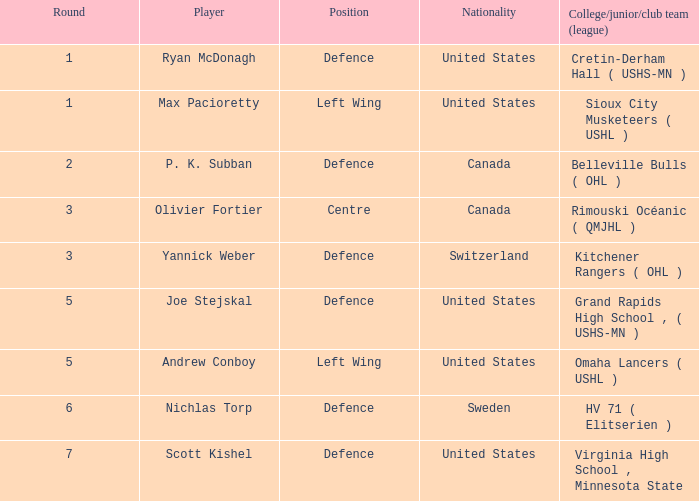Write the full table. {'header': ['Round', 'Player', 'Position', 'Nationality', 'College/junior/club team (league)'], 'rows': [['1', 'Ryan McDonagh', 'Defence', 'United States', 'Cretin-Derham Hall ( USHS-MN )'], ['1', 'Max Pacioretty', 'Left Wing', 'United States', 'Sioux City Musketeers ( USHL )'], ['2', 'P. K. Subban', 'Defence', 'Canada', 'Belleville Bulls ( OHL )'], ['3', 'Olivier Fortier', 'Centre', 'Canada', 'Rimouski Océanic ( QMJHL )'], ['3', 'Yannick Weber', 'Defence', 'Switzerland', 'Kitchener Rangers ( OHL )'], ['5', 'Joe Stejskal', 'Defence', 'United States', 'Grand Rapids High School , ( USHS-MN )'], ['5', 'Andrew Conboy', 'Left Wing', 'United States', 'Omaha Lancers ( USHL )'], ['6', 'Nichlas Torp', 'Defence', 'Sweden', 'HV 71 ( Elitserien )'], ['7', 'Scott Kishel', 'Defence', 'United States', 'Virginia High School , Minnesota State']]} Which u.s. player who plays defense was picked prior to round 5? Ryan McDonagh. 